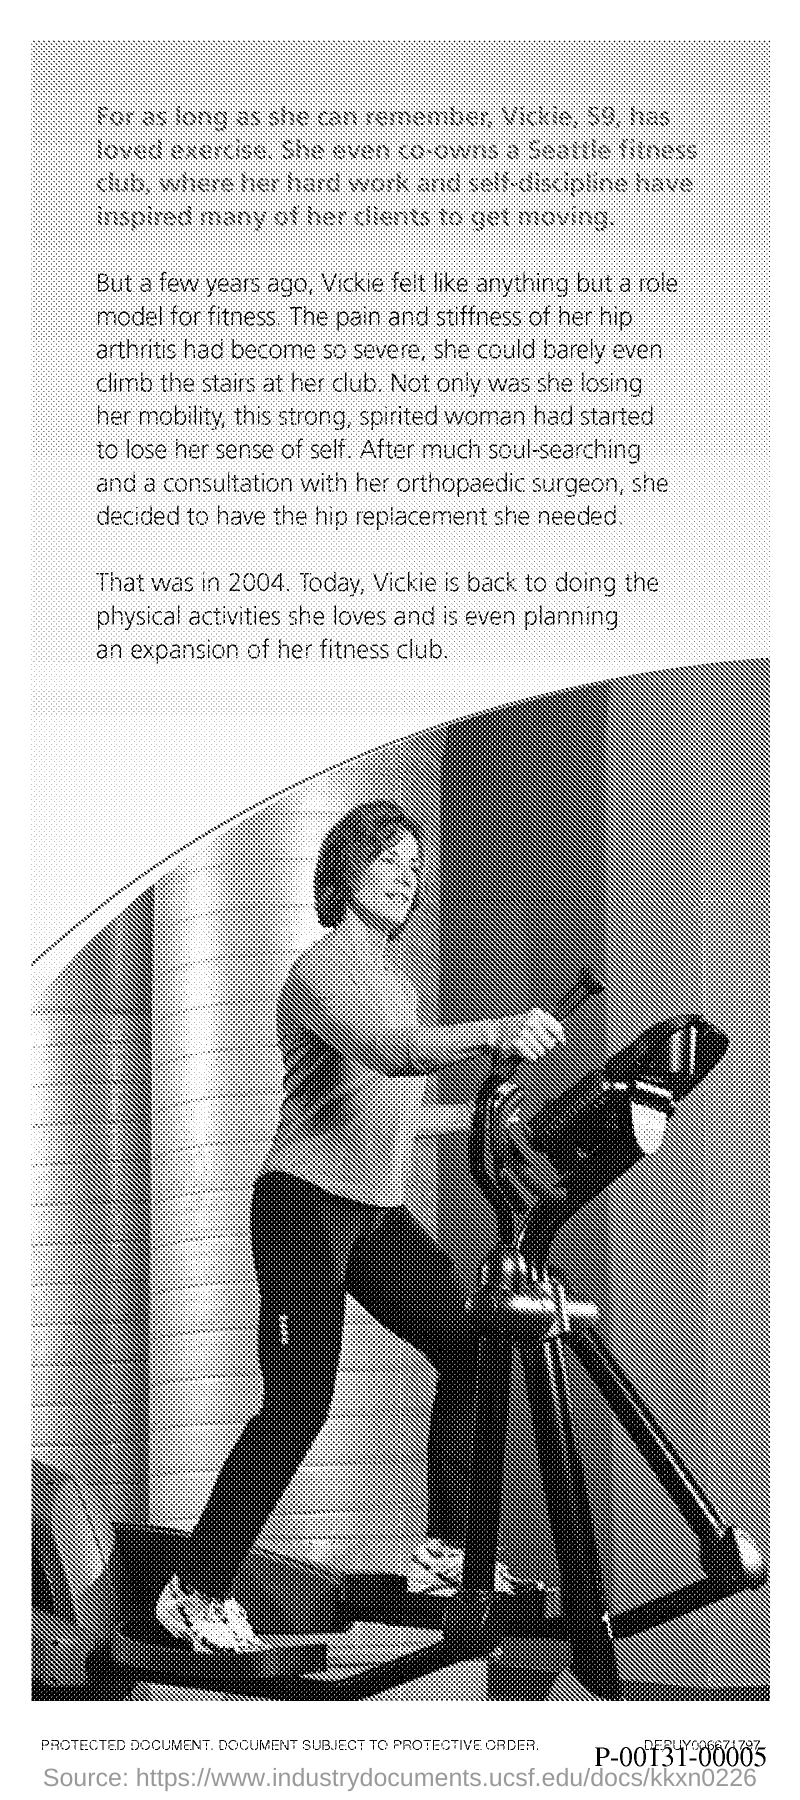What is age of Vicky?
Give a very brief answer. 59. Vicky had a consultation with which surgeon?
Offer a terse response. Orthopaedic surgeon. In which year did Vickie had her hip surgery?
Provide a succinct answer. 2004. 